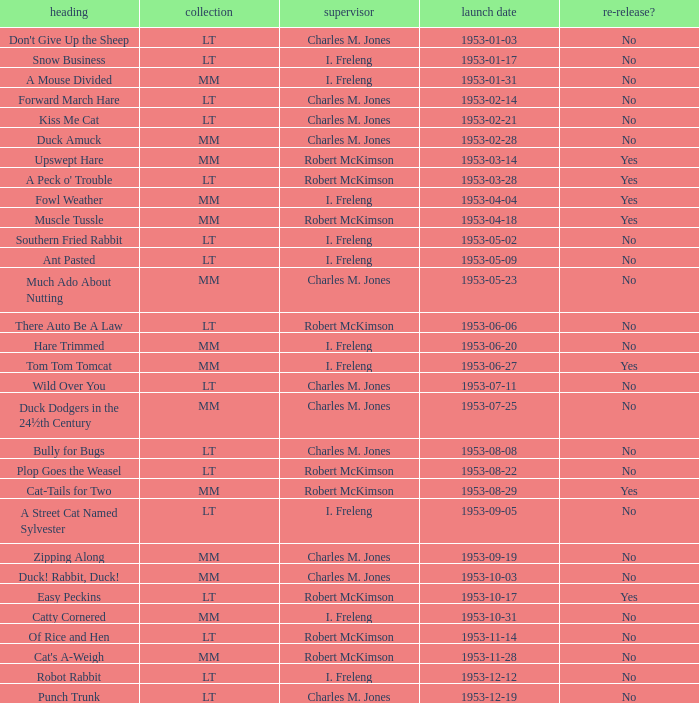What's the release date of Forward March Hare? 1953-02-14. 